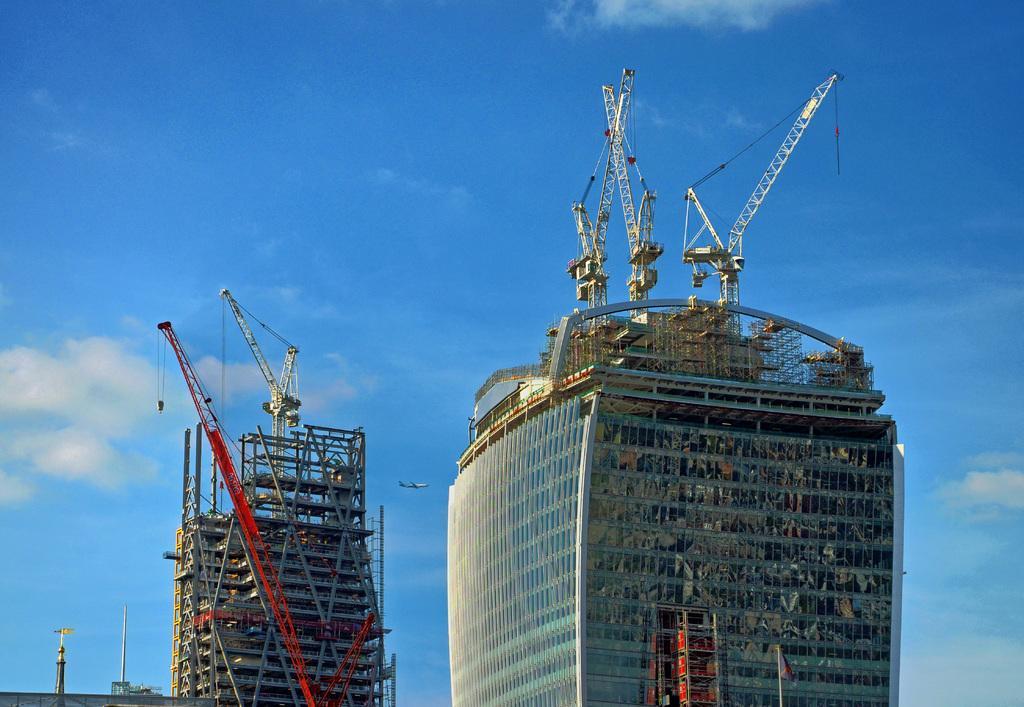Can you describe this image briefly? In this image we can see there are buildings, cranes and poles. In the background we can see cloudy sky. 